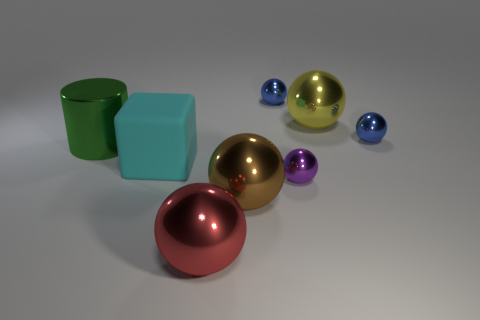Subtract all small blue metallic balls. How many balls are left? 4 Add 1 blue objects. How many objects exist? 9 Subtract all yellow spheres. How many spheres are left? 5 Subtract 1 spheres. How many spheres are left? 5 Subtract all cyan cubes. How many blue spheres are left? 2 Add 4 red things. How many red things exist? 5 Subtract 0 purple blocks. How many objects are left? 8 Subtract all blocks. How many objects are left? 7 Subtract all red cubes. Subtract all red cylinders. How many cubes are left? 1 Subtract all tiny gray blocks. Subtract all balls. How many objects are left? 2 